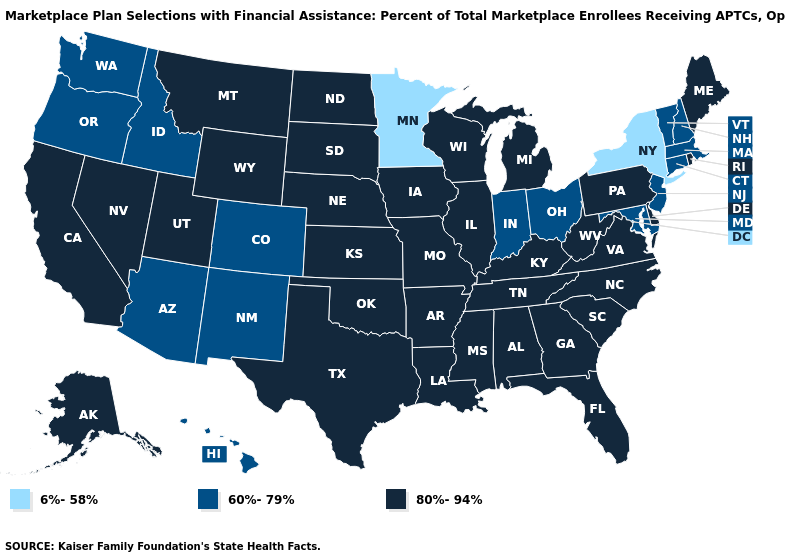What is the lowest value in the USA?
Quick response, please. 6%-58%. Does Nebraska have the lowest value in the MidWest?
Short answer required. No. Among the states that border Virginia , does Maryland have the lowest value?
Keep it brief. Yes. What is the value of Virginia?
Concise answer only. 80%-94%. How many symbols are there in the legend?
Concise answer only. 3. Does Arizona have the highest value in the USA?
Answer briefly. No. Does Illinois have the lowest value in the USA?
Write a very short answer. No. Does North Dakota have the highest value in the MidWest?
Be succinct. Yes. What is the value of Michigan?
Keep it brief. 80%-94%. Is the legend a continuous bar?
Answer briefly. No. What is the value of North Carolina?
Keep it brief. 80%-94%. What is the value of Maine?
Quick response, please. 80%-94%. What is the value of Indiana?
Give a very brief answer. 60%-79%. What is the value of South Dakota?
Be succinct. 80%-94%. Does the map have missing data?
Write a very short answer. No. 